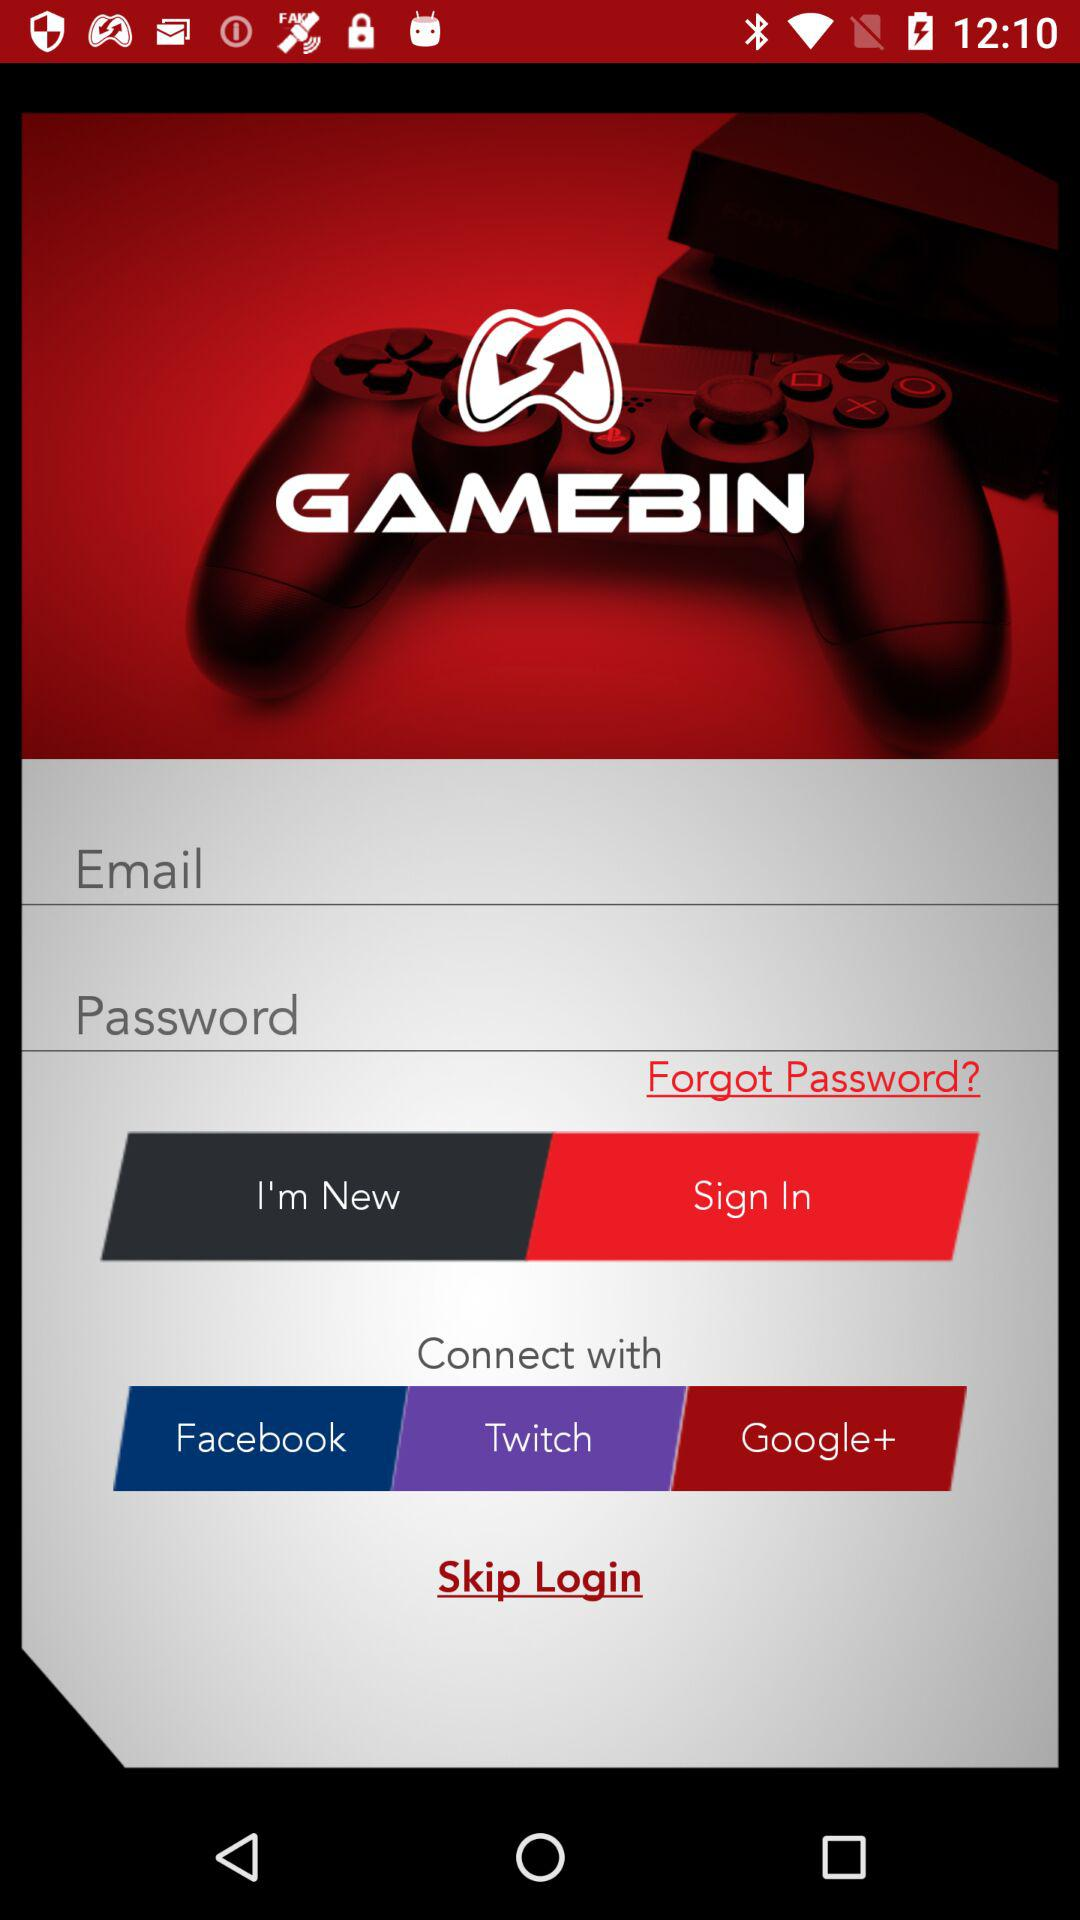Through which Accounts user can connect? User can connect with Facebook, Twitch and Google+. 